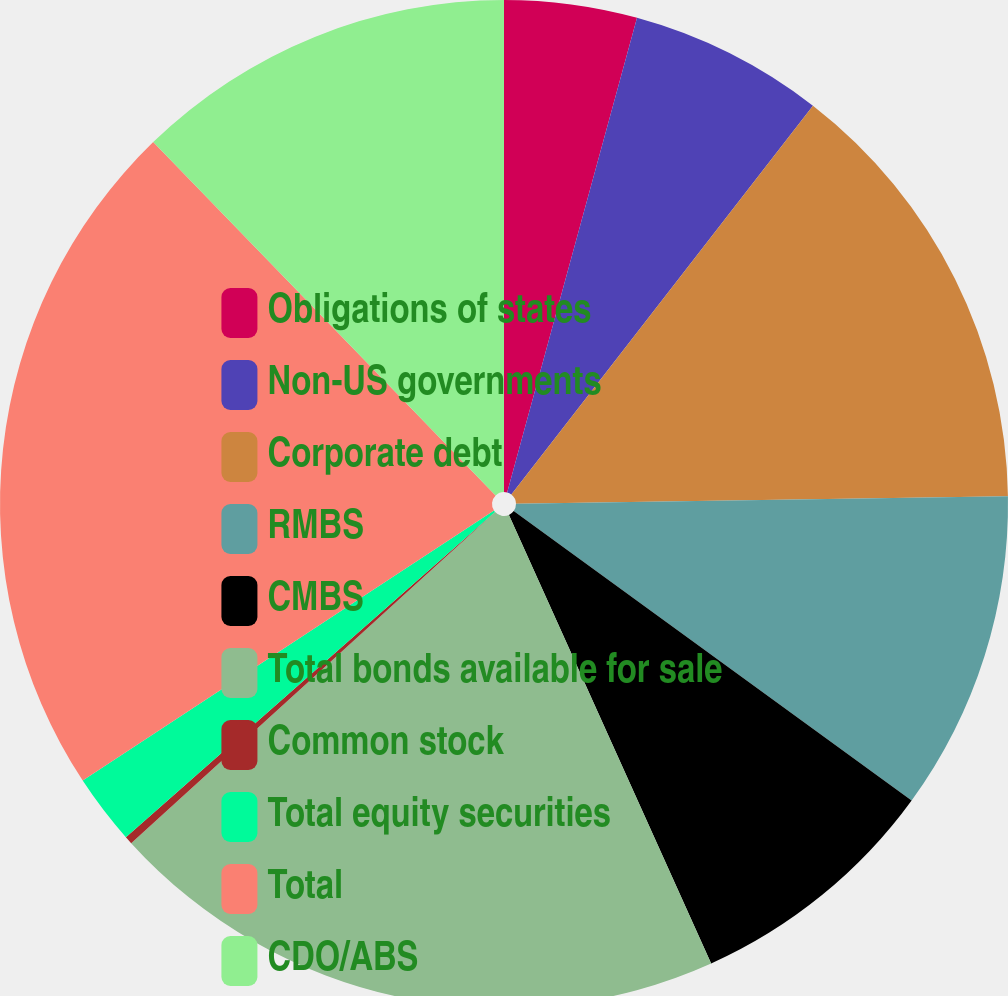Convert chart. <chart><loc_0><loc_0><loc_500><loc_500><pie_chart><fcel>Obligations of states<fcel>Non-US governments<fcel>Corporate debt<fcel>RMBS<fcel>CMBS<fcel>Total bonds available for sale<fcel>Common stock<fcel>Total equity securities<fcel>Total<fcel>CDO/ABS<nl><fcel>4.25%<fcel>6.25%<fcel>14.25%<fcel>10.25%<fcel>8.25%<fcel>19.99%<fcel>0.25%<fcel>2.25%<fcel>21.99%<fcel>12.25%<nl></chart> 